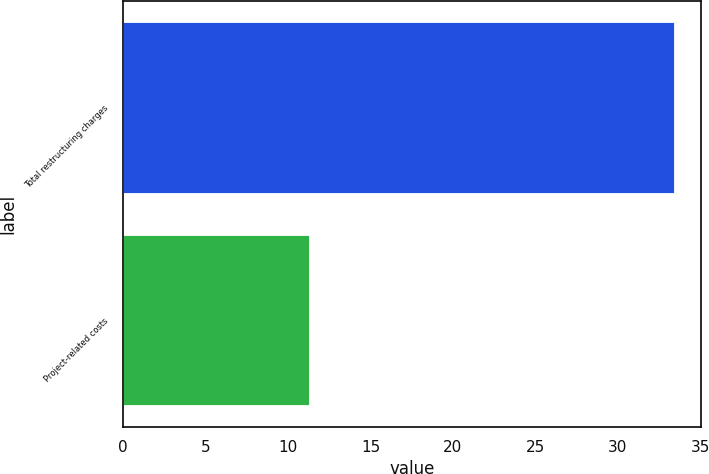Convert chart to OTSL. <chart><loc_0><loc_0><loc_500><loc_500><bar_chart><fcel>Total restructuring charges<fcel>Project-related costs<nl><fcel>33.4<fcel>11.3<nl></chart> 